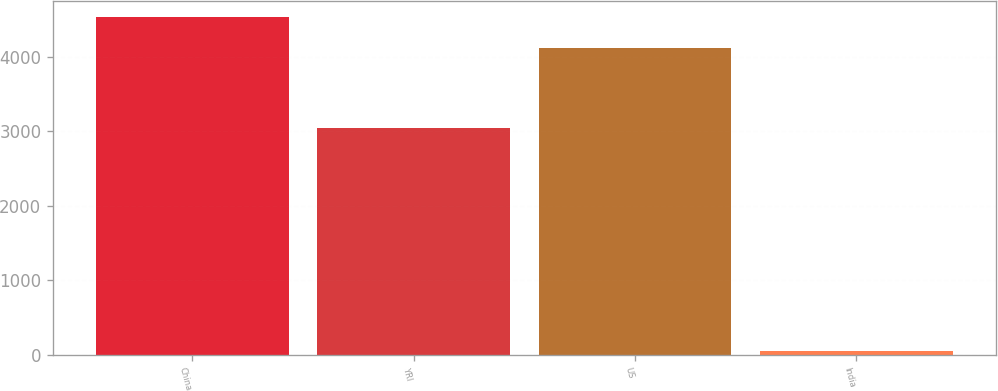Convert chart. <chart><loc_0><loc_0><loc_500><loc_500><bar_chart><fcel>China<fcel>YRI<fcel>US<fcel>India<nl><fcel>4528.6<fcel>3039<fcel>4120<fcel>49<nl></chart> 